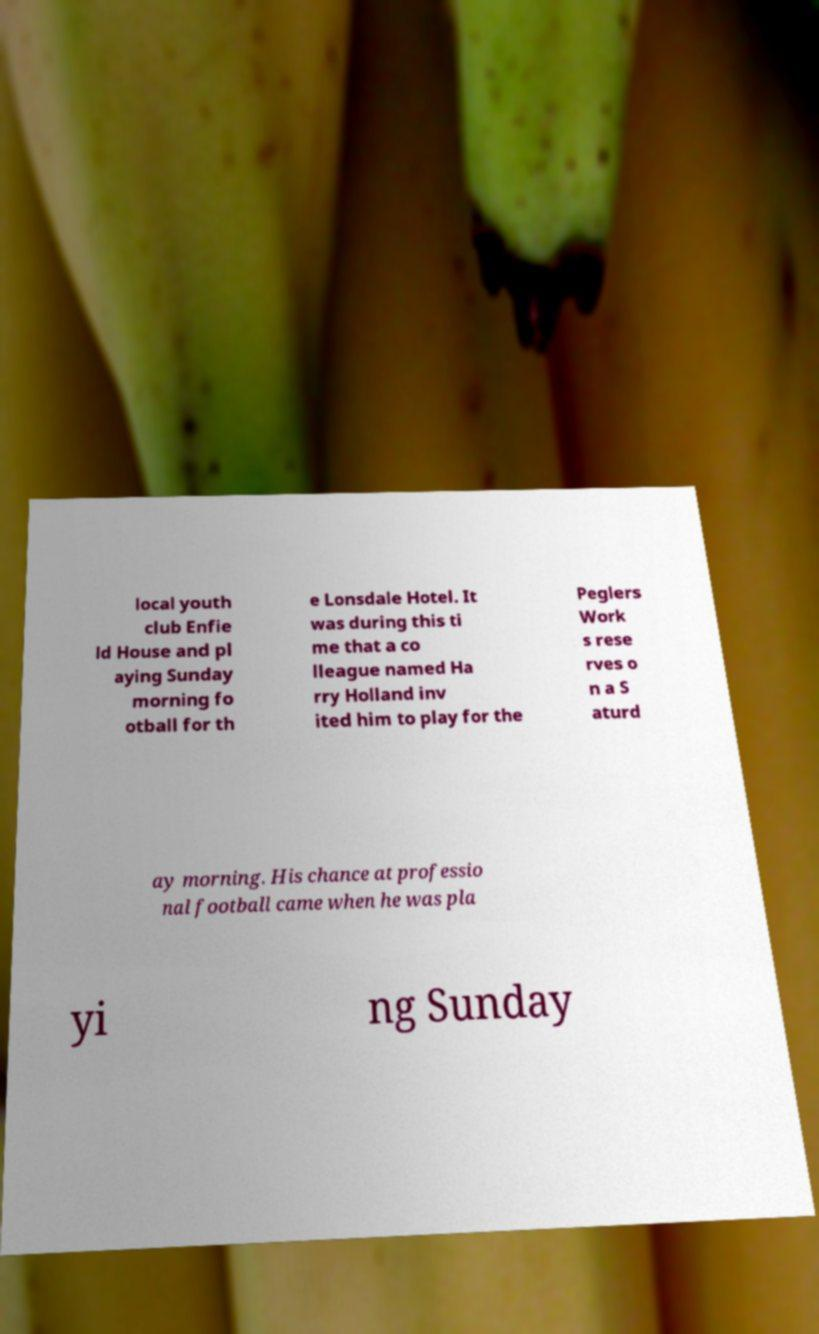Could you extract and type out the text from this image? local youth club Enfie ld House and pl aying Sunday morning fo otball for th e Lonsdale Hotel. It was during this ti me that a co lleague named Ha rry Holland inv ited him to play for the Peglers Work s rese rves o n a S aturd ay morning. His chance at professio nal football came when he was pla yi ng Sunday 